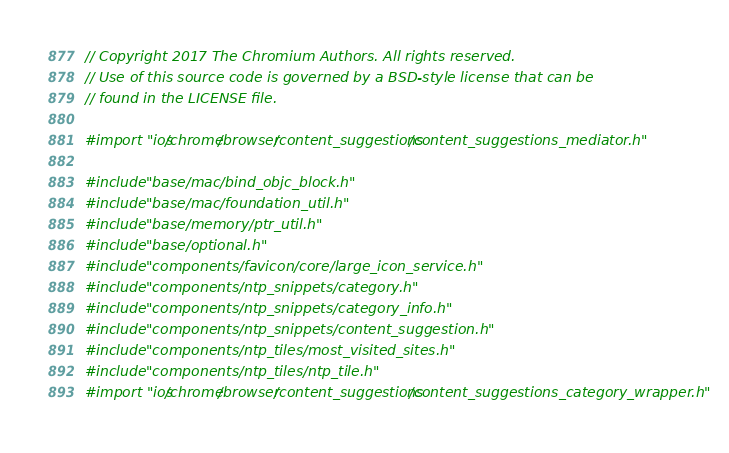Convert code to text. <code><loc_0><loc_0><loc_500><loc_500><_ObjectiveC_>// Copyright 2017 The Chromium Authors. All rights reserved.
// Use of this source code is governed by a BSD-style license that can be
// found in the LICENSE file.

#import "ios/chrome/browser/content_suggestions/content_suggestions_mediator.h"

#include "base/mac/bind_objc_block.h"
#include "base/mac/foundation_util.h"
#include "base/memory/ptr_util.h"
#include "base/optional.h"
#include "components/favicon/core/large_icon_service.h"
#include "components/ntp_snippets/category.h"
#include "components/ntp_snippets/category_info.h"
#include "components/ntp_snippets/content_suggestion.h"
#include "components/ntp_tiles/most_visited_sites.h"
#include "components/ntp_tiles/ntp_tile.h"
#import "ios/chrome/browser/content_suggestions/content_suggestions_category_wrapper.h"</code> 